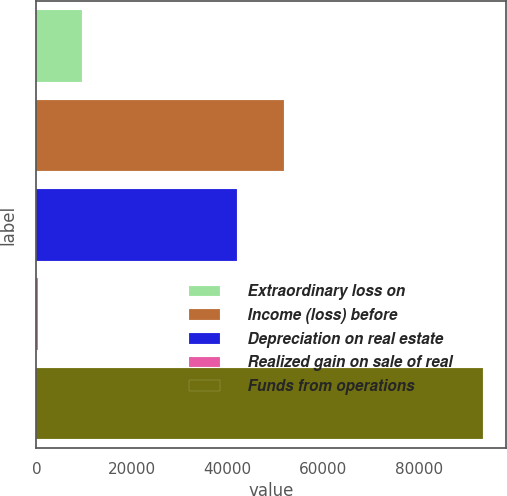Convert chart to OTSL. <chart><loc_0><loc_0><loc_500><loc_500><bar_chart><fcel>Extraordinary loss on<fcel>Income (loss) before<fcel>Depreciation on real estate<fcel>Realized gain on sale of real<fcel>Funds from operations<nl><fcel>9611.2<fcel>51888<fcel>41904<fcel>290<fcel>93502<nl></chart> 